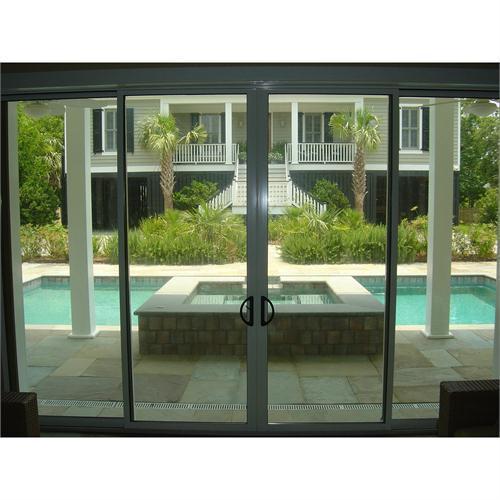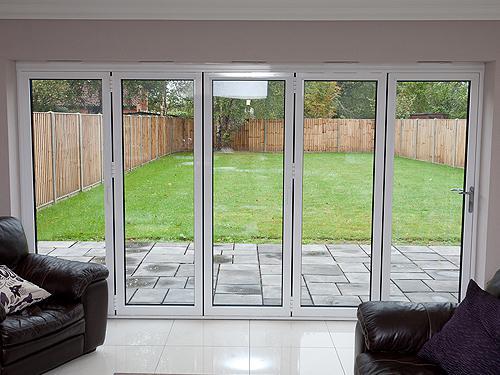The first image is the image on the left, the second image is the image on the right. For the images displayed, is the sentence "there is a home with sliding glass doors open and looking into a living area from the outside" factually correct? Answer yes or no. No. The first image is the image on the left, the second image is the image on the right. Given the left and right images, does the statement "The right image is an exterior view of a white dark-framed sliding door unit, opened to show a furnished home interior." hold true? Answer yes or no. No. 